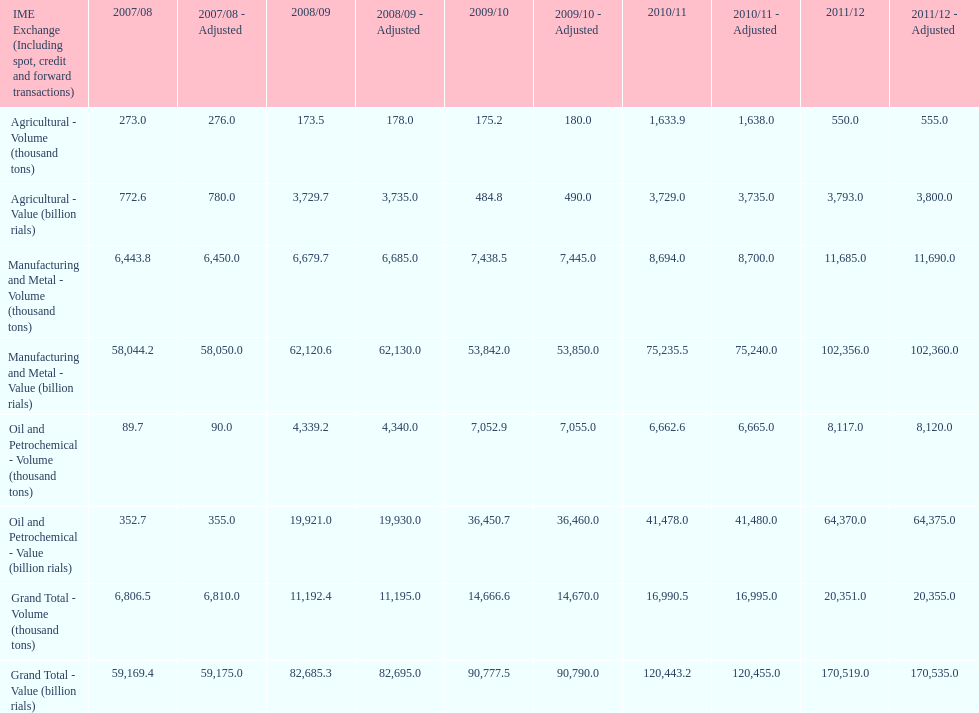What is the total agricultural value in 2008/09? 3,729.7. 